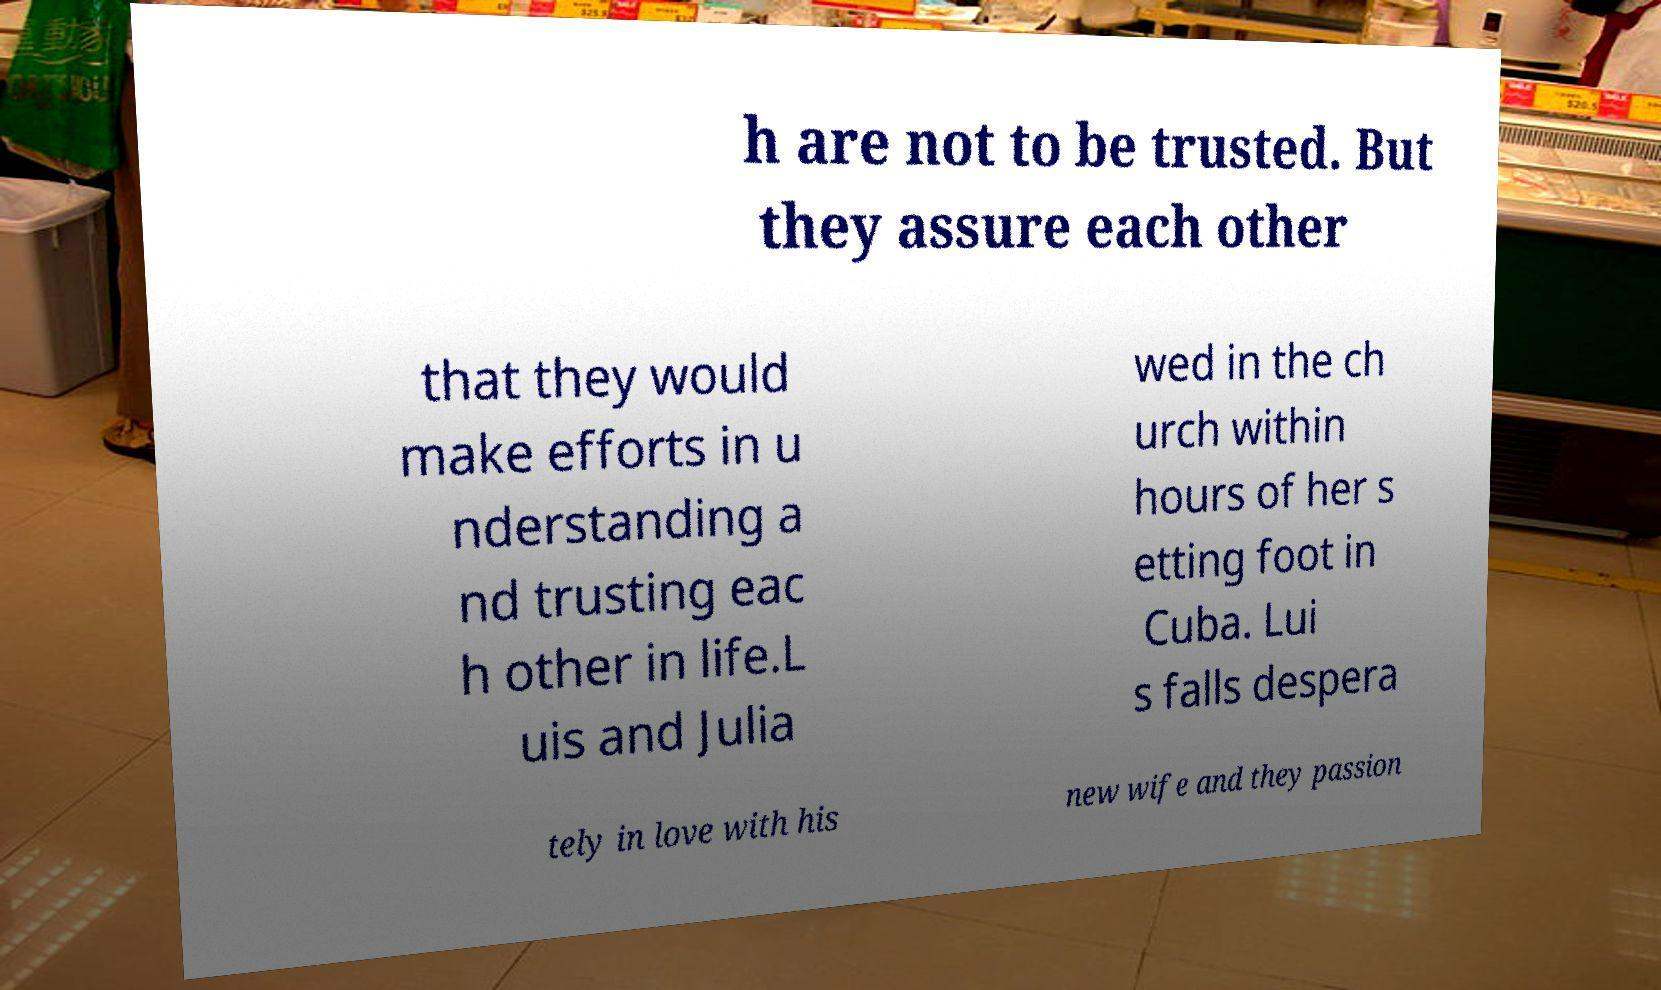Could you extract and type out the text from this image? h are not to be trusted. But they assure each other that they would make efforts in u nderstanding a nd trusting eac h other in life.L uis and Julia wed in the ch urch within hours of her s etting foot in Cuba. Lui s falls despera tely in love with his new wife and they passion 